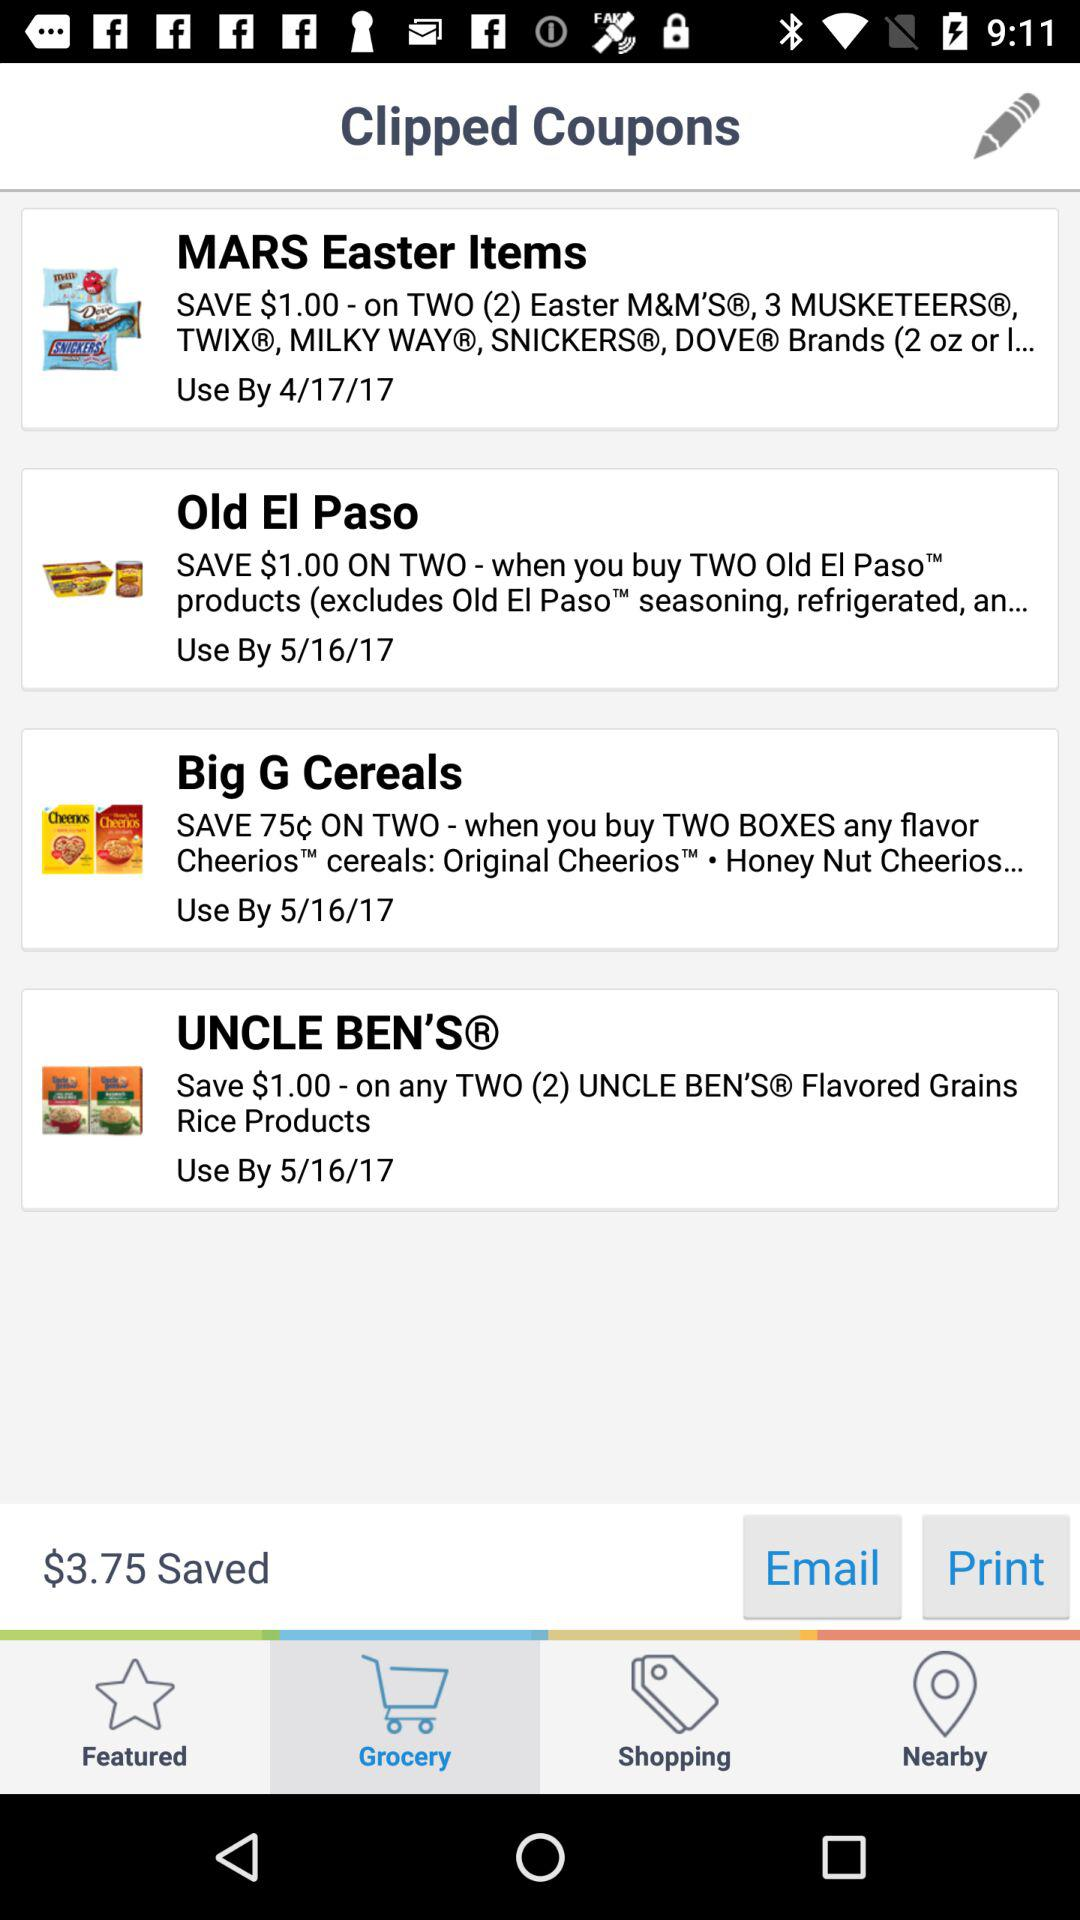How much amount is saved? The saved amount is $3.75. 